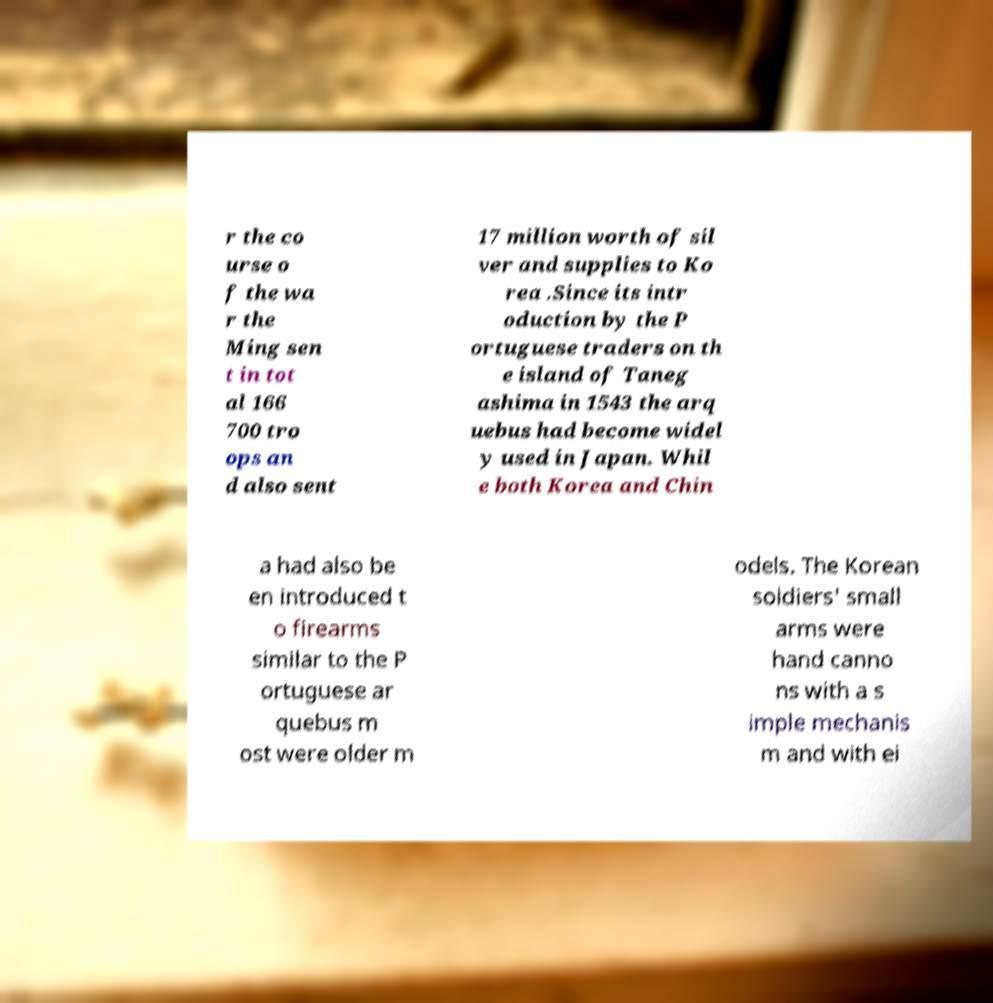Can you read and provide the text displayed in the image?This photo seems to have some interesting text. Can you extract and type it out for me? r the co urse o f the wa r the Ming sen t in tot al 166 700 tro ops an d also sent 17 million worth of sil ver and supplies to Ko rea .Since its intr oduction by the P ortuguese traders on th e island of Taneg ashima in 1543 the arq uebus had become widel y used in Japan. Whil e both Korea and Chin a had also be en introduced t o firearms similar to the P ortuguese ar quebus m ost were older m odels. The Korean soldiers' small arms were hand canno ns with a s imple mechanis m and with ei 